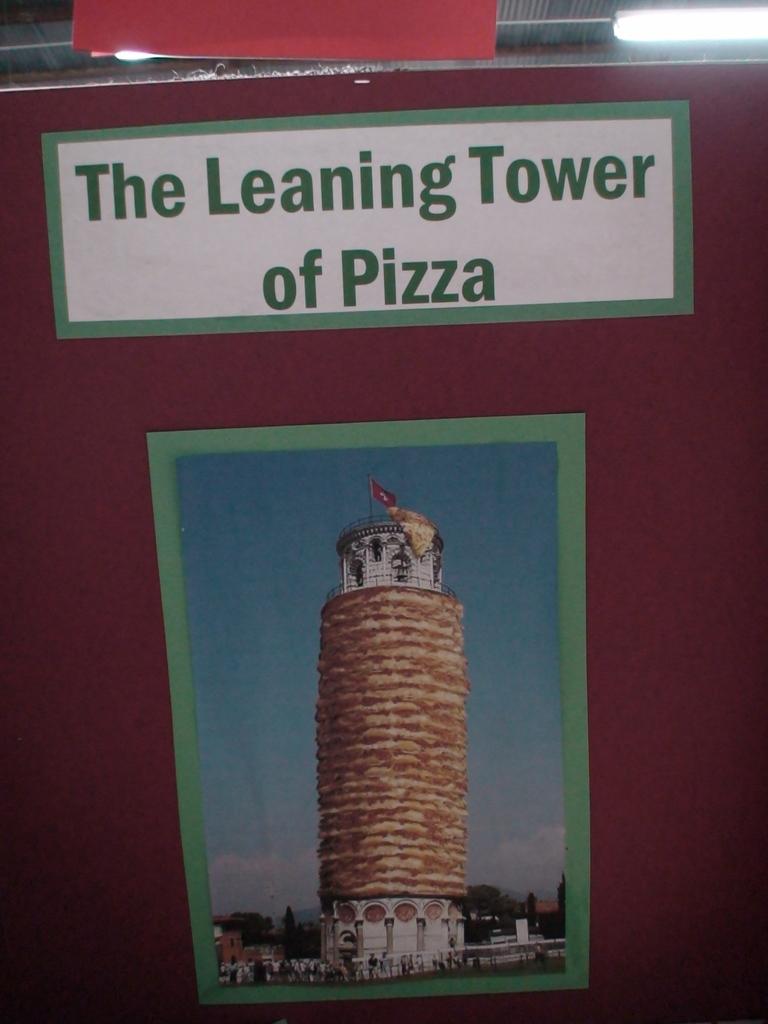What tower is shown?
Keep it short and to the point. The leaning tower of pizza. 